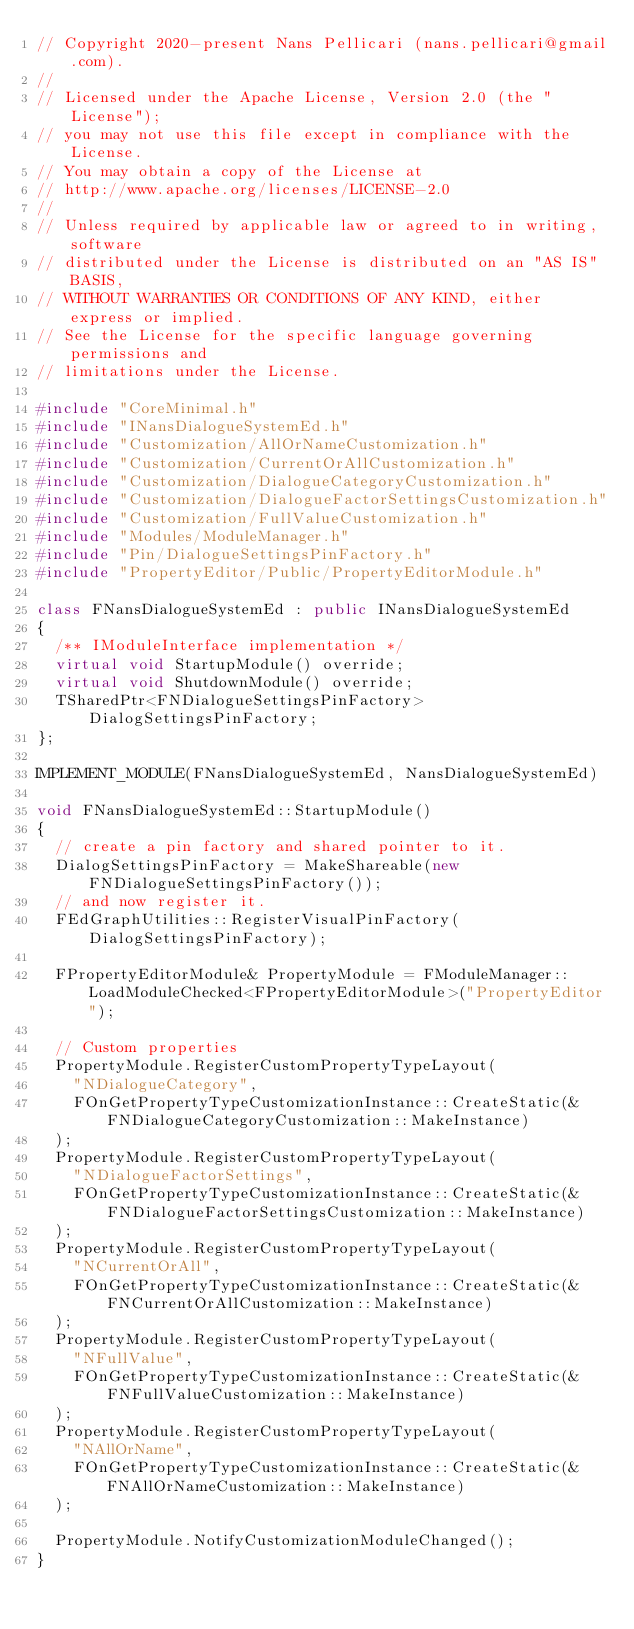<code> <loc_0><loc_0><loc_500><loc_500><_C++_>// Copyright 2020-present Nans Pellicari (nans.pellicari@gmail.com).
// 
// Licensed under the Apache License, Version 2.0 (the "License");
// you may not use this file except in compliance with the License.
// You may obtain a copy of the License at
// http://www.apache.org/licenses/LICENSE-2.0
// 
// Unless required by applicable law or agreed to in writing, software
// distributed under the License is distributed on an "AS IS" BASIS,
// WITHOUT WARRANTIES OR CONDITIONS OF ANY KIND, either express or implied.
// See the License for the specific language governing permissions and
// limitations under the License.

#include "CoreMinimal.h"
#include "INansDialogueSystemEd.h"
#include "Customization/AllOrNameCustomization.h"
#include "Customization/CurrentOrAllCustomization.h"
#include "Customization/DialogueCategoryCustomization.h"
#include "Customization/DialogueFactorSettingsCustomization.h"
#include "Customization/FullValueCustomization.h"
#include "Modules/ModuleManager.h"
#include "Pin/DialogueSettingsPinFactory.h"
#include "PropertyEditor/Public/PropertyEditorModule.h"

class FNansDialogueSystemEd : public INansDialogueSystemEd
{
	/** IModuleInterface implementation */
	virtual void StartupModule() override;
	virtual void ShutdownModule() override;
	TSharedPtr<FNDialogueSettingsPinFactory> DialogSettingsPinFactory;
};

IMPLEMENT_MODULE(FNansDialogueSystemEd, NansDialogueSystemEd)

void FNansDialogueSystemEd::StartupModule()
{
	// create a pin factory and shared pointer to it.
	DialogSettingsPinFactory = MakeShareable(new FNDialogueSettingsPinFactory());
	// and now register it.
	FEdGraphUtilities::RegisterVisualPinFactory(DialogSettingsPinFactory);

	FPropertyEditorModule& PropertyModule = FModuleManager::LoadModuleChecked<FPropertyEditorModule>("PropertyEditor");

	// Custom properties
	PropertyModule.RegisterCustomPropertyTypeLayout(
		"NDialogueCategory",
		FOnGetPropertyTypeCustomizationInstance::CreateStatic(&FNDialogueCategoryCustomization::MakeInstance)
	);
	PropertyModule.RegisterCustomPropertyTypeLayout(
		"NDialogueFactorSettings",
		FOnGetPropertyTypeCustomizationInstance::CreateStatic(&FNDialogueFactorSettingsCustomization::MakeInstance)
	);
	PropertyModule.RegisterCustomPropertyTypeLayout(
		"NCurrentOrAll",
		FOnGetPropertyTypeCustomizationInstance::CreateStatic(&FNCurrentOrAllCustomization::MakeInstance)
	);
	PropertyModule.RegisterCustomPropertyTypeLayout(
		"NFullValue",
		FOnGetPropertyTypeCustomizationInstance::CreateStatic(&FNFullValueCustomization::MakeInstance)
	);
	PropertyModule.RegisterCustomPropertyTypeLayout(
		"NAllOrName",
		FOnGetPropertyTypeCustomizationInstance::CreateStatic(&FNAllOrNameCustomization::MakeInstance)
	);

	PropertyModule.NotifyCustomizationModuleChanged();
}
</code> 